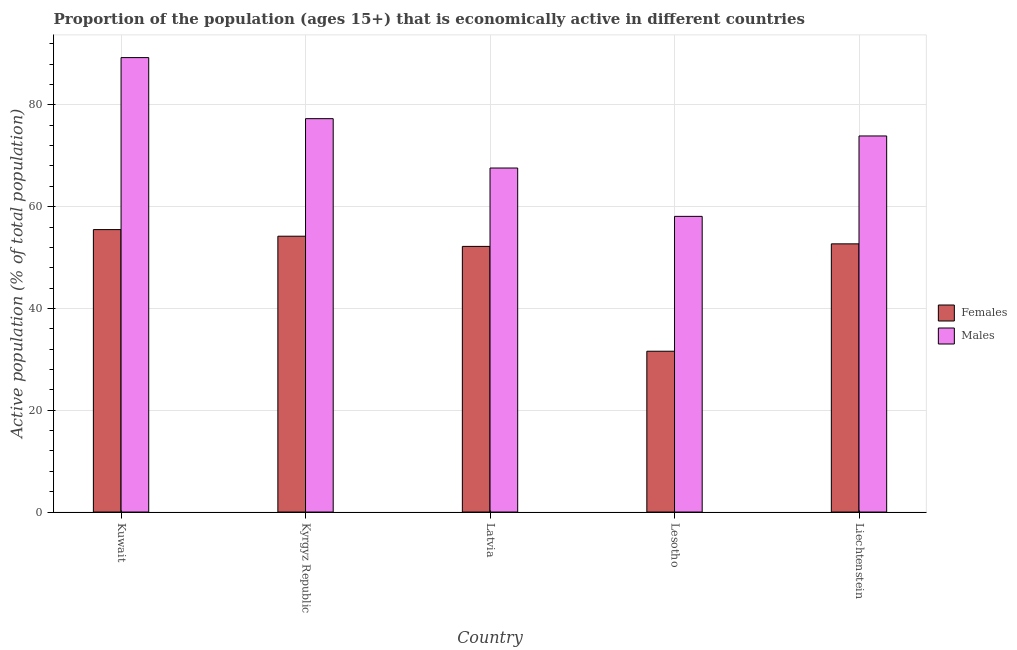How many different coloured bars are there?
Keep it short and to the point. 2. How many groups of bars are there?
Your answer should be very brief. 5. Are the number of bars per tick equal to the number of legend labels?
Offer a very short reply. Yes. How many bars are there on the 2nd tick from the left?
Offer a very short reply. 2. What is the label of the 5th group of bars from the left?
Keep it short and to the point. Liechtenstein. What is the percentage of economically active male population in Liechtenstein?
Make the answer very short. 73.9. Across all countries, what is the maximum percentage of economically active male population?
Your answer should be very brief. 89.3. Across all countries, what is the minimum percentage of economically active male population?
Your answer should be compact. 58.1. In which country was the percentage of economically active female population maximum?
Make the answer very short. Kuwait. In which country was the percentage of economically active male population minimum?
Your response must be concise. Lesotho. What is the total percentage of economically active female population in the graph?
Make the answer very short. 246.2. What is the difference between the percentage of economically active male population in Kyrgyz Republic and that in Liechtenstein?
Offer a very short reply. 3.4. What is the difference between the percentage of economically active female population in Kuwait and the percentage of economically active male population in Latvia?
Your response must be concise. -12.1. What is the average percentage of economically active male population per country?
Offer a very short reply. 73.24. What is the difference between the percentage of economically active male population and percentage of economically active female population in Lesotho?
Keep it short and to the point. 26.5. What is the ratio of the percentage of economically active male population in Kuwait to that in Lesotho?
Your answer should be compact. 1.54. What is the difference between the highest and the lowest percentage of economically active male population?
Your response must be concise. 31.2. In how many countries, is the percentage of economically active female population greater than the average percentage of economically active female population taken over all countries?
Your response must be concise. 4. Is the sum of the percentage of economically active female population in Kuwait and Liechtenstein greater than the maximum percentage of economically active male population across all countries?
Ensure brevity in your answer.  Yes. What does the 2nd bar from the left in Latvia represents?
Give a very brief answer. Males. What does the 2nd bar from the right in Kuwait represents?
Give a very brief answer. Females. How many countries are there in the graph?
Offer a terse response. 5. Are the values on the major ticks of Y-axis written in scientific E-notation?
Provide a succinct answer. No. Does the graph contain any zero values?
Give a very brief answer. No. Does the graph contain grids?
Your response must be concise. Yes. How many legend labels are there?
Provide a short and direct response. 2. How are the legend labels stacked?
Give a very brief answer. Vertical. What is the title of the graph?
Keep it short and to the point. Proportion of the population (ages 15+) that is economically active in different countries. What is the label or title of the X-axis?
Your answer should be compact. Country. What is the label or title of the Y-axis?
Offer a very short reply. Active population (% of total population). What is the Active population (% of total population) in Females in Kuwait?
Your response must be concise. 55.5. What is the Active population (% of total population) of Males in Kuwait?
Offer a terse response. 89.3. What is the Active population (% of total population) in Females in Kyrgyz Republic?
Your answer should be compact. 54.2. What is the Active population (% of total population) of Males in Kyrgyz Republic?
Keep it short and to the point. 77.3. What is the Active population (% of total population) of Females in Latvia?
Your response must be concise. 52.2. What is the Active population (% of total population) of Males in Latvia?
Make the answer very short. 67.6. What is the Active population (% of total population) in Females in Lesotho?
Your answer should be very brief. 31.6. What is the Active population (% of total population) of Males in Lesotho?
Provide a succinct answer. 58.1. What is the Active population (% of total population) in Females in Liechtenstein?
Keep it short and to the point. 52.7. What is the Active population (% of total population) in Males in Liechtenstein?
Your answer should be compact. 73.9. Across all countries, what is the maximum Active population (% of total population) of Females?
Your answer should be compact. 55.5. Across all countries, what is the maximum Active population (% of total population) of Males?
Offer a very short reply. 89.3. Across all countries, what is the minimum Active population (% of total population) of Females?
Ensure brevity in your answer.  31.6. Across all countries, what is the minimum Active population (% of total population) in Males?
Provide a succinct answer. 58.1. What is the total Active population (% of total population) in Females in the graph?
Make the answer very short. 246.2. What is the total Active population (% of total population) in Males in the graph?
Your answer should be very brief. 366.2. What is the difference between the Active population (% of total population) of Females in Kuwait and that in Kyrgyz Republic?
Ensure brevity in your answer.  1.3. What is the difference between the Active population (% of total population) of Males in Kuwait and that in Kyrgyz Republic?
Your answer should be very brief. 12. What is the difference between the Active population (% of total population) in Males in Kuwait and that in Latvia?
Make the answer very short. 21.7. What is the difference between the Active population (% of total population) of Females in Kuwait and that in Lesotho?
Offer a terse response. 23.9. What is the difference between the Active population (% of total population) of Males in Kuwait and that in Lesotho?
Offer a very short reply. 31.2. What is the difference between the Active population (% of total population) in Females in Kuwait and that in Liechtenstein?
Offer a terse response. 2.8. What is the difference between the Active population (% of total population) in Females in Kyrgyz Republic and that in Latvia?
Your answer should be compact. 2. What is the difference between the Active population (% of total population) in Females in Kyrgyz Republic and that in Lesotho?
Keep it short and to the point. 22.6. What is the difference between the Active population (% of total population) of Males in Kyrgyz Republic and that in Lesotho?
Provide a succinct answer. 19.2. What is the difference between the Active population (% of total population) of Females in Kyrgyz Republic and that in Liechtenstein?
Offer a terse response. 1.5. What is the difference between the Active population (% of total population) of Males in Kyrgyz Republic and that in Liechtenstein?
Keep it short and to the point. 3.4. What is the difference between the Active population (% of total population) of Females in Latvia and that in Lesotho?
Make the answer very short. 20.6. What is the difference between the Active population (% of total population) in Males in Latvia and that in Lesotho?
Your answer should be compact. 9.5. What is the difference between the Active population (% of total population) of Females in Latvia and that in Liechtenstein?
Your answer should be compact. -0.5. What is the difference between the Active population (% of total population) of Males in Latvia and that in Liechtenstein?
Offer a terse response. -6.3. What is the difference between the Active population (% of total population) in Females in Lesotho and that in Liechtenstein?
Provide a succinct answer. -21.1. What is the difference between the Active population (% of total population) of Males in Lesotho and that in Liechtenstein?
Offer a very short reply. -15.8. What is the difference between the Active population (% of total population) in Females in Kuwait and the Active population (% of total population) in Males in Kyrgyz Republic?
Provide a succinct answer. -21.8. What is the difference between the Active population (% of total population) in Females in Kuwait and the Active population (% of total population) in Males in Latvia?
Provide a short and direct response. -12.1. What is the difference between the Active population (% of total population) in Females in Kuwait and the Active population (% of total population) in Males in Liechtenstein?
Give a very brief answer. -18.4. What is the difference between the Active population (% of total population) in Females in Kyrgyz Republic and the Active population (% of total population) in Males in Lesotho?
Make the answer very short. -3.9. What is the difference between the Active population (% of total population) in Females in Kyrgyz Republic and the Active population (% of total population) in Males in Liechtenstein?
Your response must be concise. -19.7. What is the difference between the Active population (% of total population) of Females in Latvia and the Active population (% of total population) of Males in Liechtenstein?
Your answer should be very brief. -21.7. What is the difference between the Active population (% of total population) in Females in Lesotho and the Active population (% of total population) in Males in Liechtenstein?
Provide a short and direct response. -42.3. What is the average Active population (% of total population) of Females per country?
Ensure brevity in your answer.  49.24. What is the average Active population (% of total population) in Males per country?
Ensure brevity in your answer.  73.24. What is the difference between the Active population (% of total population) of Females and Active population (% of total population) of Males in Kuwait?
Make the answer very short. -33.8. What is the difference between the Active population (% of total population) in Females and Active population (% of total population) in Males in Kyrgyz Republic?
Give a very brief answer. -23.1. What is the difference between the Active population (% of total population) in Females and Active population (% of total population) in Males in Latvia?
Offer a very short reply. -15.4. What is the difference between the Active population (% of total population) of Females and Active population (% of total population) of Males in Lesotho?
Provide a short and direct response. -26.5. What is the difference between the Active population (% of total population) of Females and Active population (% of total population) of Males in Liechtenstein?
Provide a short and direct response. -21.2. What is the ratio of the Active population (% of total population) in Males in Kuwait to that in Kyrgyz Republic?
Offer a very short reply. 1.16. What is the ratio of the Active population (% of total population) of Females in Kuwait to that in Latvia?
Your answer should be compact. 1.06. What is the ratio of the Active population (% of total population) in Males in Kuwait to that in Latvia?
Provide a succinct answer. 1.32. What is the ratio of the Active population (% of total population) in Females in Kuwait to that in Lesotho?
Your response must be concise. 1.76. What is the ratio of the Active population (% of total population) in Males in Kuwait to that in Lesotho?
Provide a short and direct response. 1.54. What is the ratio of the Active population (% of total population) in Females in Kuwait to that in Liechtenstein?
Ensure brevity in your answer.  1.05. What is the ratio of the Active population (% of total population) of Males in Kuwait to that in Liechtenstein?
Your answer should be very brief. 1.21. What is the ratio of the Active population (% of total population) of Females in Kyrgyz Republic to that in Latvia?
Offer a very short reply. 1.04. What is the ratio of the Active population (% of total population) in Males in Kyrgyz Republic to that in Latvia?
Make the answer very short. 1.14. What is the ratio of the Active population (% of total population) of Females in Kyrgyz Republic to that in Lesotho?
Offer a very short reply. 1.72. What is the ratio of the Active population (% of total population) in Males in Kyrgyz Republic to that in Lesotho?
Your response must be concise. 1.33. What is the ratio of the Active population (% of total population) in Females in Kyrgyz Republic to that in Liechtenstein?
Your answer should be very brief. 1.03. What is the ratio of the Active population (% of total population) of Males in Kyrgyz Republic to that in Liechtenstein?
Your answer should be compact. 1.05. What is the ratio of the Active population (% of total population) in Females in Latvia to that in Lesotho?
Keep it short and to the point. 1.65. What is the ratio of the Active population (% of total population) of Males in Latvia to that in Lesotho?
Provide a succinct answer. 1.16. What is the ratio of the Active population (% of total population) of Males in Latvia to that in Liechtenstein?
Give a very brief answer. 0.91. What is the ratio of the Active population (% of total population) of Females in Lesotho to that in Liechtenstein?
Give a very brief answer. 0.6. What is the ratio of the Active population (% of total population) in Males in Lesotho to that in Liechtenstein?
Provide a succinct answer. 0.79. What is the difference between the highest and the second highest Active population (% of total population) in Females?
Your answer should be very brief. 1.3. What is the difference between the highest and the lowest Active population (% of total population) of Females?
Make the answer very short. 23.9. What is the difference between the highest and the lowest Active population (% of total population) of Males?
Offer a very short reply. 31.2. 